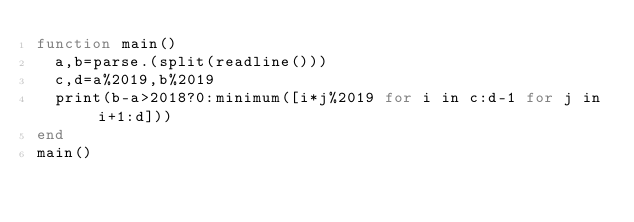<code> <loc_0><loc_0><loc_500><loc_500><_Julia_>function main()
	a,b=parse.(split(readline()))
	c,d=a%2019,b%2019
	print(b-a>2018?0:minimum([i*j%2019 for i in c:d-1 for j in i+1:d]))
end
main()</code> 